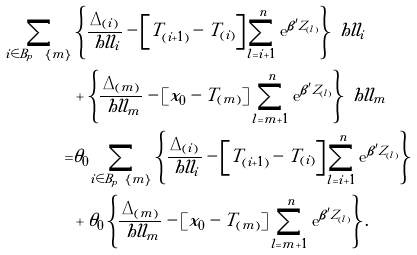<formula> <loc_0><loc_0><loc_500><loc_500>\sum _ { i \in B _ { p } \ { \{ m \} } } & \left \{ \frac { \Delta _ { ( i ) } } { \ h l l _ { i } } - \left [ T _ { ( i + 1 ) } - T _ { ( i ) } \right ] \sum _ { l = i + 1 } ^ { n } \text {e} ^ { \beta ^ { \prime } Z _ { ( l ) } } \right \} \ h l l _ { i } \\ & + \left \{ \frac { \Delta _ { ( m ) } } { \ h l l _ { m } } - \left [ x _ { 0 } - T _ { ( m ) } \right ] \sum _ { l = m + 1 } ^ { n } \text {e} ^ { \beta ^ { \prime } Z _ { ( l ) } } \right \} \ h l l _ { m } \\ = & \theta _ { 0 } \sum _ { i \in B _ { p } \ { \{ m \} } } \left \{ \frac { \Delta _ { ( i ) } } { \ h l l _ { i } } - \left [ T _ { ( i + 1 ) } - T _ { ( i ) } \right ] \sum _ { l = i + 1 } ^ { n } \text {e} ^ { \beta ^ { \prime } Z _ { ( l ) } } \right \} \\ & + \theta _ { 0 } \left \{ \frac { \Delta _ { ( m ) } } { \ h l l _ { m } } - \left [ x _ { 0 } - T _ { ( m ) } \right ] \sum _ { l = m + 1 } ^ { n } \text {e} ^ { \beta ^ { \prime } Z _ { ( l ) } } \right \} .</formula> 